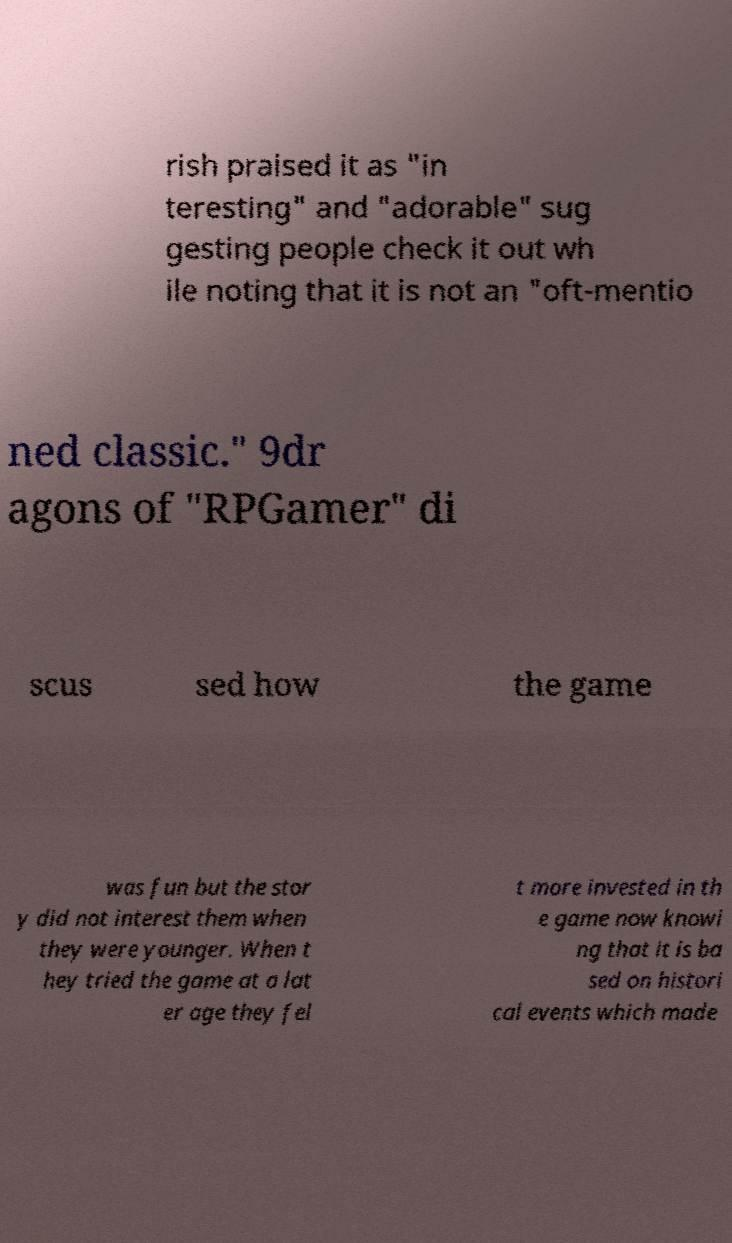Can you read and provide the text displayed in the image?This photo seems to have some interesting text. Can you extract and type it out for me? rish praised it as "in teresting" and "adorable" sug gesting people check it out wh ile noting that it is not an "oft-mentio ned classic." 9dr agons of "RPGamer" di scus sed how the game was fun but the stor y did not interest them when they were younger. When t hey tried the game at a lat er age they fel t more invested in th e game now knowi ng that it is ba sed on histori cal events which made 